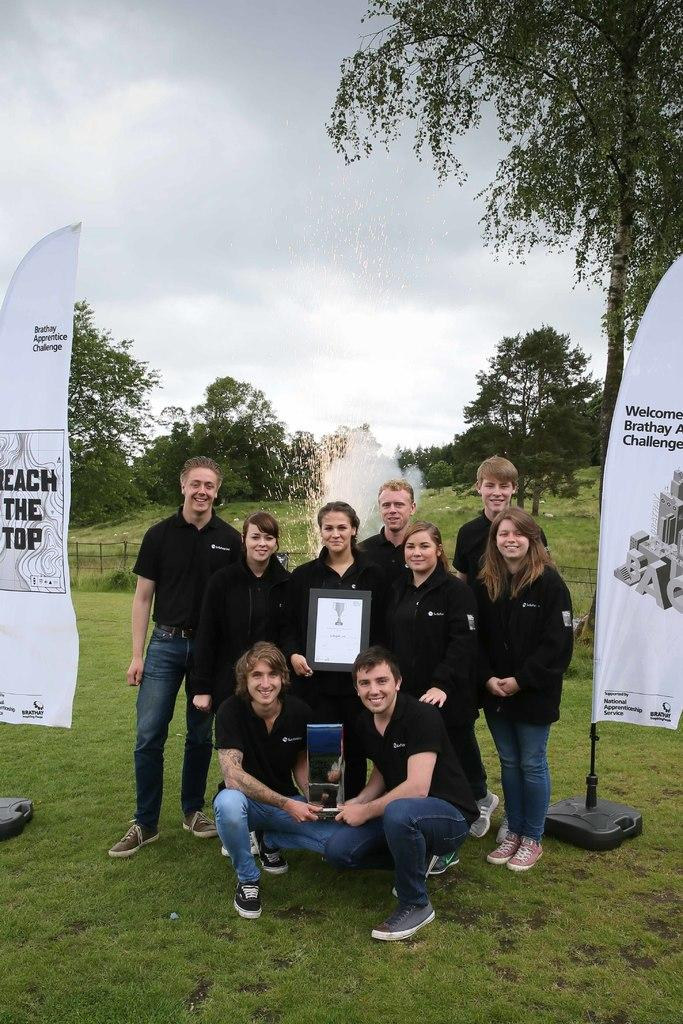What are the people in the image doing? The people in the image are standing and holding trophies. What is the ground surface like in the image? The ground is covered with grass. What can be seen in the background of the image? There are trees visible in the background. Can you tell me how many times the people in the image jump in the air? There is no indication in the image that the people are jumping in the air, so it cannot be determined from the picture. 